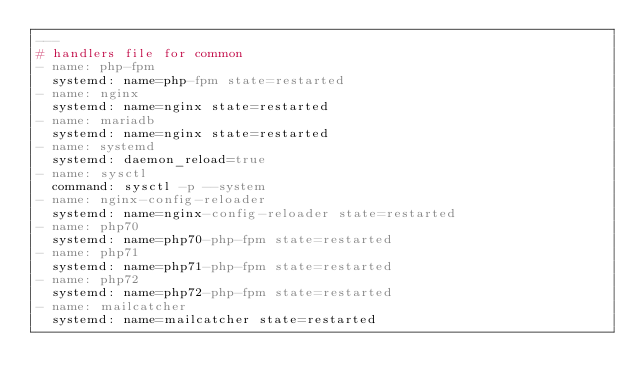Convert code to text. <code><loc_0><loc_0><loc_500><loc_500><_YAML_>---
# handlers file for common
- name: php-fpm
  systemd: name=php-fpm state=restarted
- name: nginx
  systemd: name=nginx state=restarted
- name: mariadb
  systemd: name=nginx state=restarted
- name: systemd
  systemd: daemon_reload=true
- name: sysctl
  command: sysctl -p --system
- name: nginx-config-reloader
  systemd: name=nginx-config-reloader state=restarted
- name: php70
  systemd: name=php70-php-fpm state=restarted
- name: php71
  systemd: name=php71-php-fpm state=restarted
- name: php72
  systemd: name=php72-php-fpm state=restarted
- name: mailcatcher
  systemd: name=mailcatcher state=restarted
</code> 